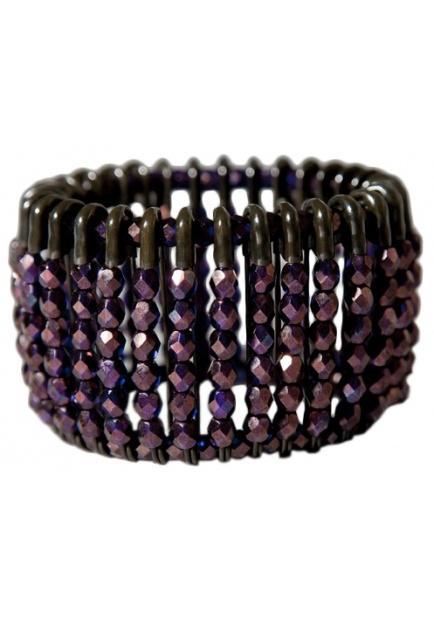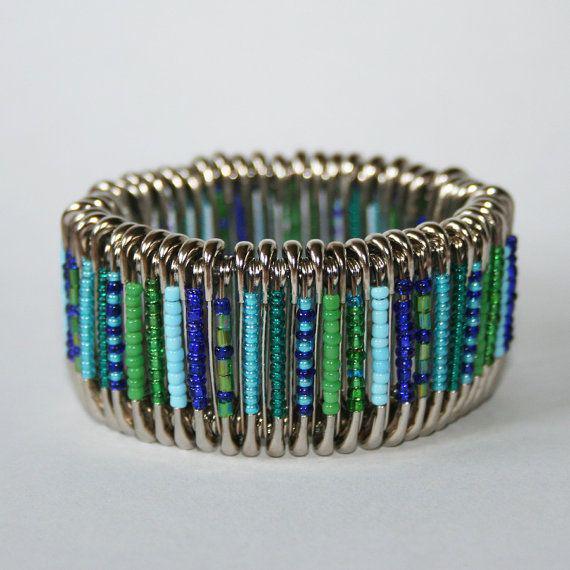The first image is the image on the left, the second image is the image on the right. For the images shown, is this caption "There are two unworn bracelets" true? Answer yes or no. Yes. The first image is the image on the left, the second image is the image on the right. Analyze the images presented: Is the assertion "An image features a beaded bracelet displayed by a black item." valid? Answer yes or no. No. 